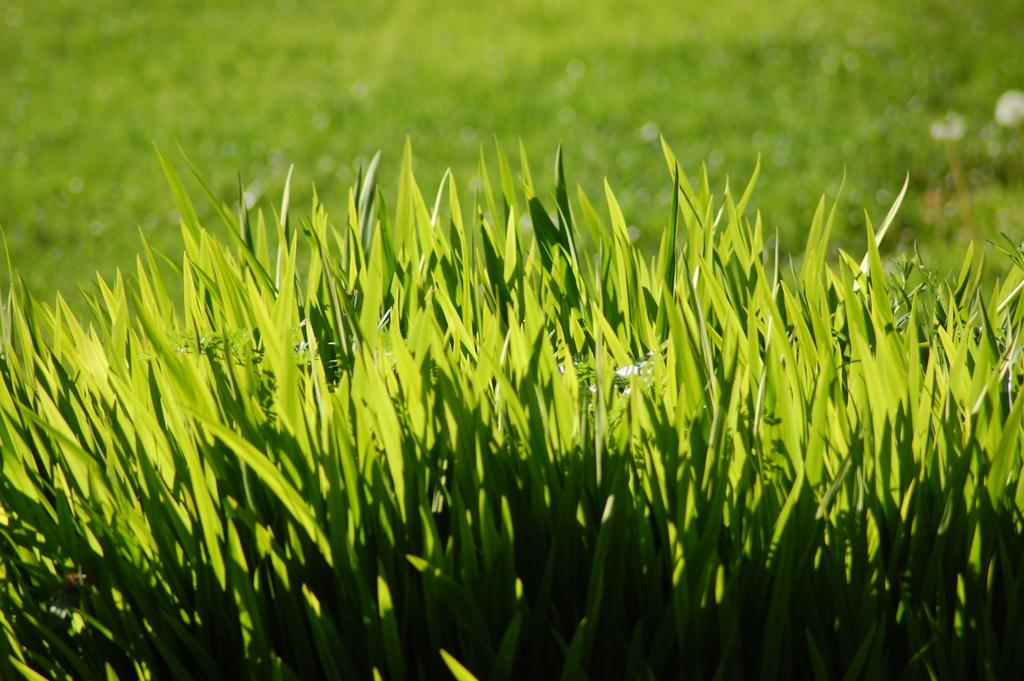What type of living organisms can be seen in the image? Plants can be seen in the image. What type of respect can be seen in the image? There is no indication of respect in the image, as it only features plants. What idea is being conveyed through the plants in the image? The image does not convey any specific idea; it simply shows plants. 